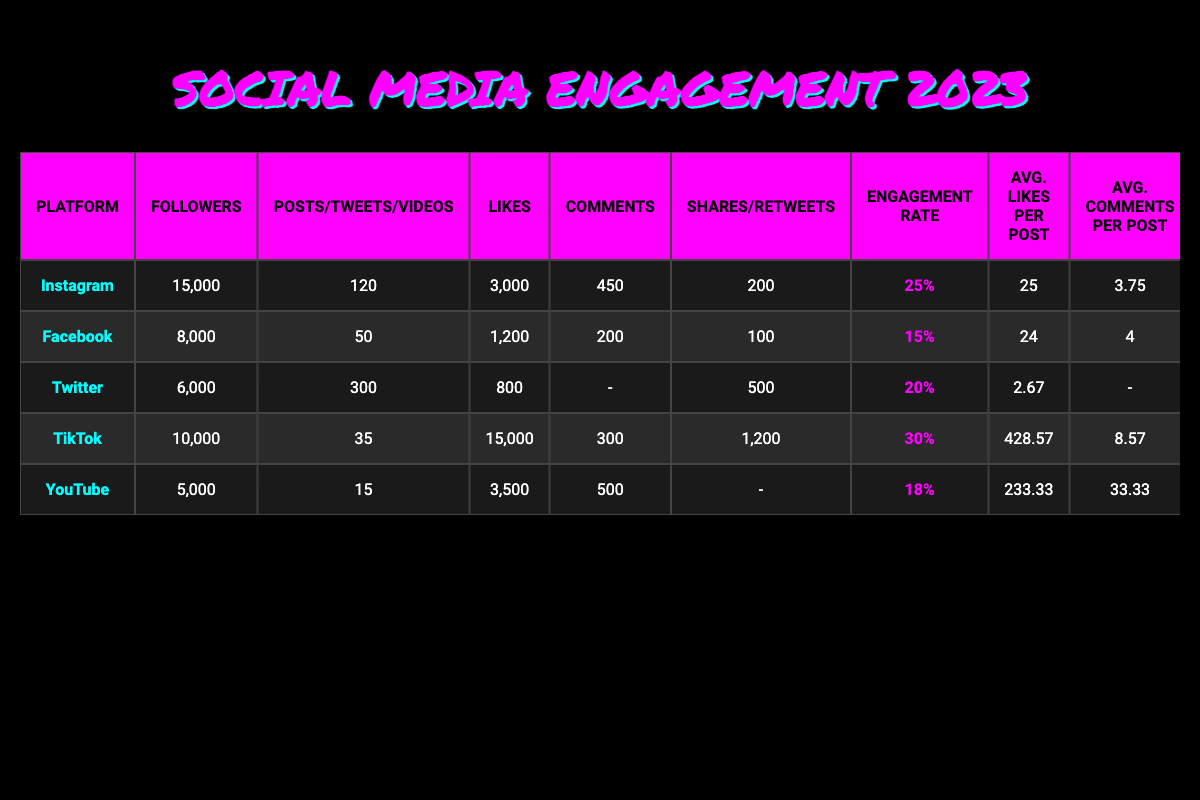What is the highest engagement rate among the social media platforms? Looking at the Engagement Rate column, TikTok shows the highest rate at 30%.
Answer: 30% How many posts did the band make on Instagram? The Posts column for Instagram lists 120 posts made by the band.
Answer: 120 What is the total number of shares (or retweets) across all platforms? Adding the shares: Instagram (200) + Facebook (100) + Twitter (500) + TikTok (1200) + YouTube (0) gives a total of 200 + 100 + 500 + 1200 + 0 = 2000 shares.
Answer: 2000 Is the number of followers on TikTok greater than on YouTube? TikTok has 10,000 followers, while YouTube has 5,000. Therefore, TikTok has more followers.
Answer: Yes What is the average engagement rate of all social media platforms? The average engagement rate is calculated as follows: (25% + 15% + 20% + 30% + 18%) / 5 = 108% / 5 = 21.6%.
Answer: 21.6% Which platform has the most likes per post? Looking at the Avg. Likes per Post column, TikTok has 428.57 likes per video, which is the highest.
Answer: 428.57 If we combine the total number of followers from Instagram and Facebook, how many followers do they have together? Adding the followers: Instagram (15,000) + Facebook (8,000) gives 15,000 + 8,000 = 23,000 followers.
Answer: 23,000 Does the average likes per tweet exceed the average comments per post on Facebook? The average likes per tweet on Twitter is 2.67 and the average comments per post on Facebook is 4. Since 2.67 is less than 4, the answer is no.
Answer: No What is the total number of comments made on all platforms combined? Adding the comments: Instagram (450) + Facebook (200) + Twitter (0) + TikTok (300) + YouTube (500) yields 450 + 200 + 0 + 300 + 500 = 1450 comments.
Answer: 1450 On which platform did the band receive the least likes? The Likes column shows that Twitter had the least with 800 likes.
Answer: Twitter 